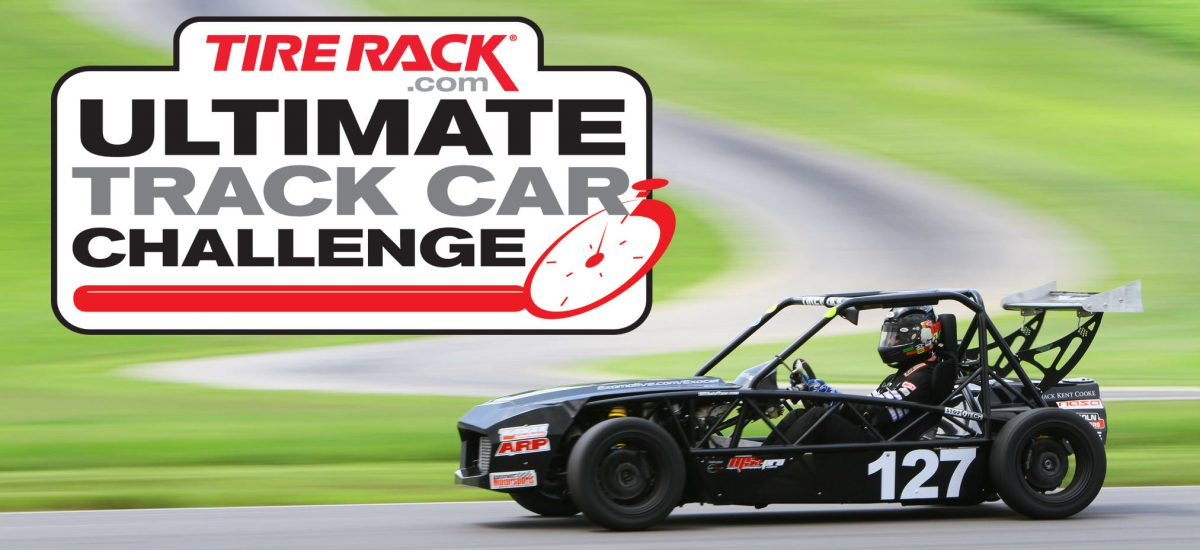Describe the level of customization that goes into building a car like the one pictured. Vehicles configured for track challenges are intensively customized. Engineers would meticulously select components to optimize power, aerodynamics, and handling. Custom fabrication is commonplace, allowing for a careful balance between weight, rigidity, and distribution. Performance tuning likely extends to the suspension setup, differential, braking systems, and even the aerodynamic elements, enabling the car to be finely adjusted to the driver's style and the specifics of each track or event. 